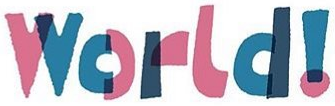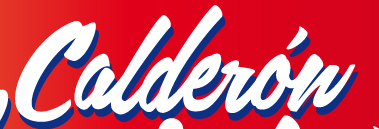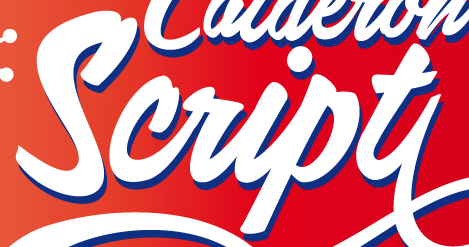What words can you see in these images in sequence, separated by a semicolon? World!; Calderów; Script 